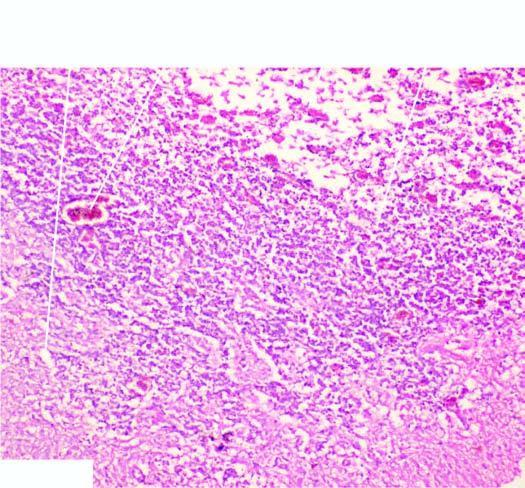re islands of invading malignant squamous cells reactive astrocytosis, a few reactive macrophages and neovascularisation in the wall of the cystic lesion?
Answer the question using a single word or phrase. No 